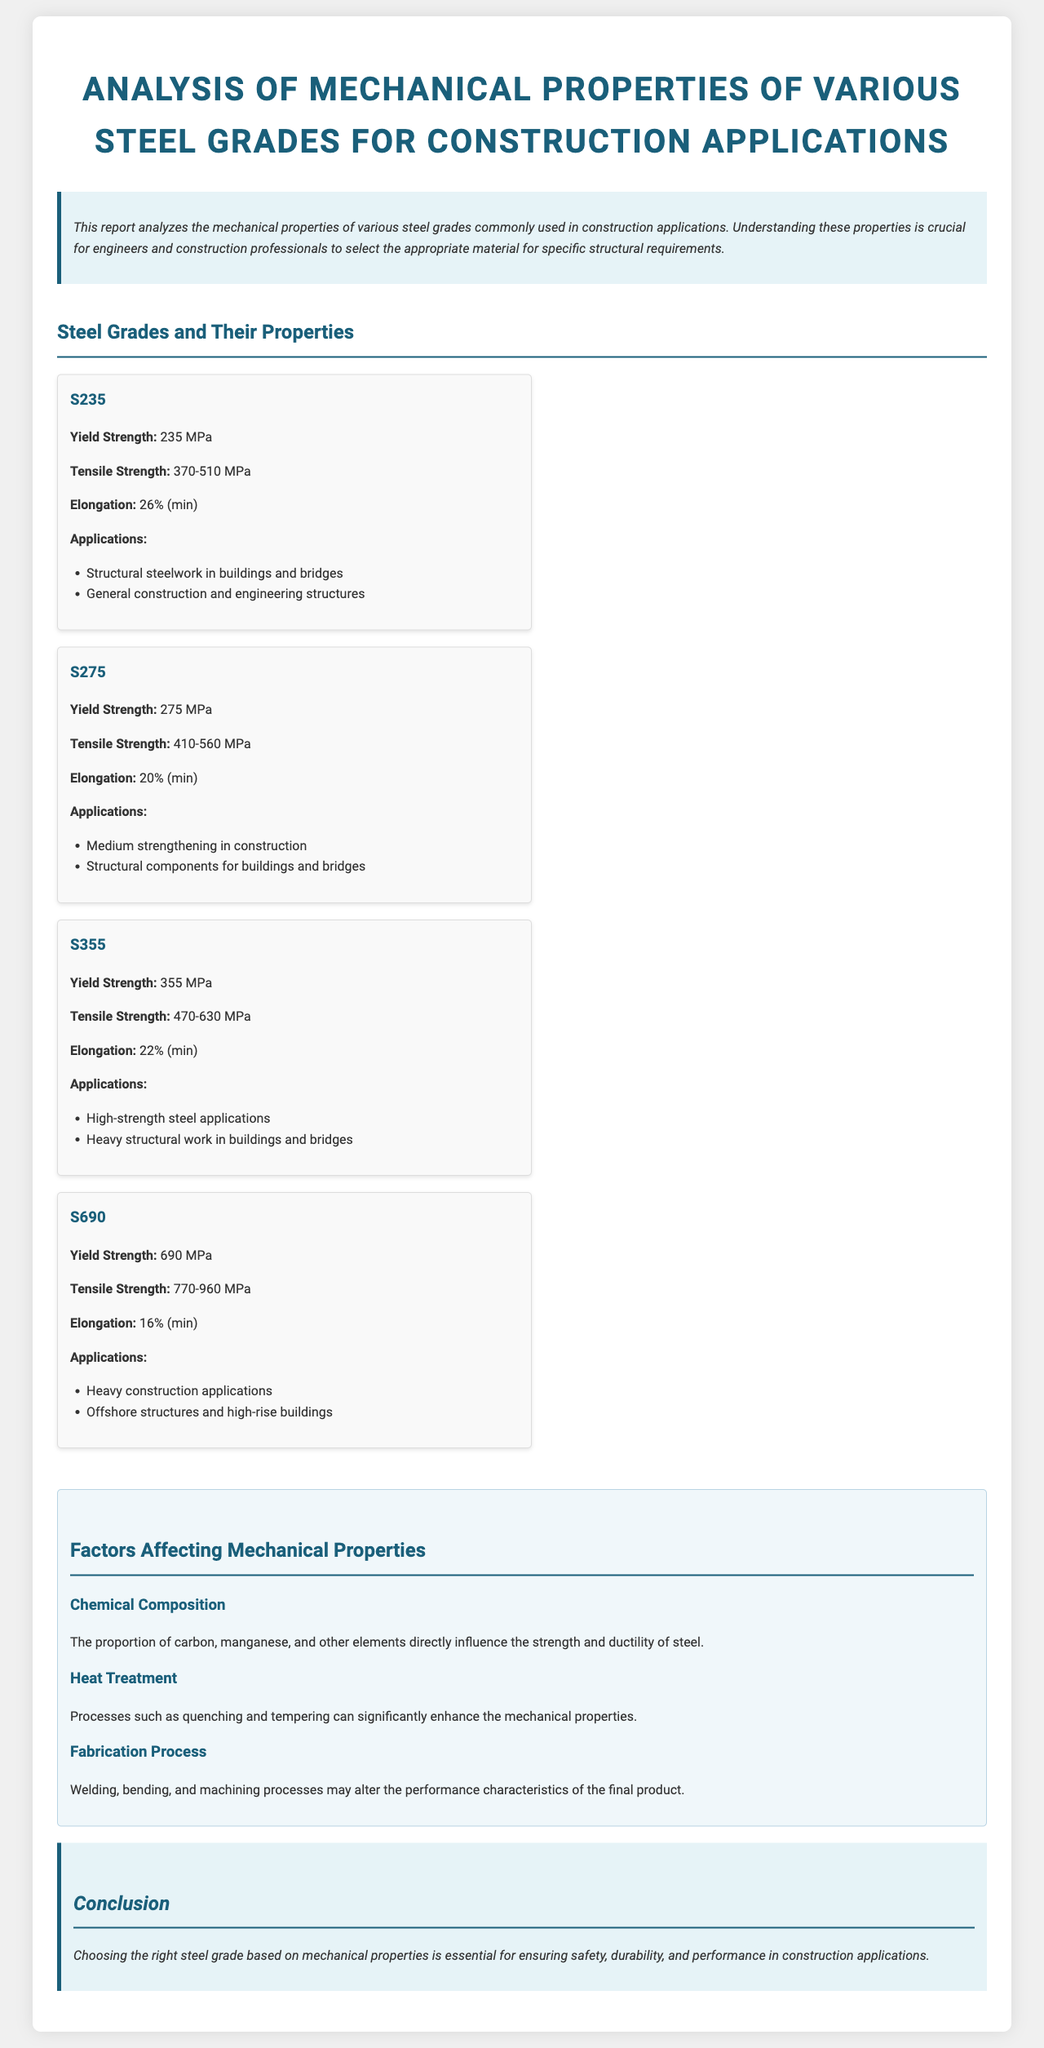What is the yield strength of S235? The yield strength of S235 is specified in the document, listed as 235 MPa.
Answer: 235 MPa What is the tensile strength range for S275? The tensile strength range for S275 is determined by the document, stated as 410-560 MPa.
Answer: 410-560 MPa Which steel grade is used for heavy construction applications? The document lists S690 as a grade used for heavy construction applications.
Answer: S690 What is the minimum elongation percentage for S690? The document indicates that the minimum elongation for S690 is 16%.
Answer: 16% What aspect of steel is influenced by chemical composition? The document mentions that the chemical composition directly influences the strength and ductility of steel.
Answer: Strength and ductility Which factors affect the mechanical properties of steel? The document outlines three factors: chemical composition, heat treatment, and fabrication process.
Answer: Chemical composition, heat treatment, fabrication process What is the primary application of S355? The document states that S355 is primarily used for high-strength steel applications.
Answer: High-strength steel applications What is the purpose of this report? The report aims to analyze mechanical properties of various steel grades for construction applications.
Answer: Analyze mechanical properties of various steel grades for construction applications 